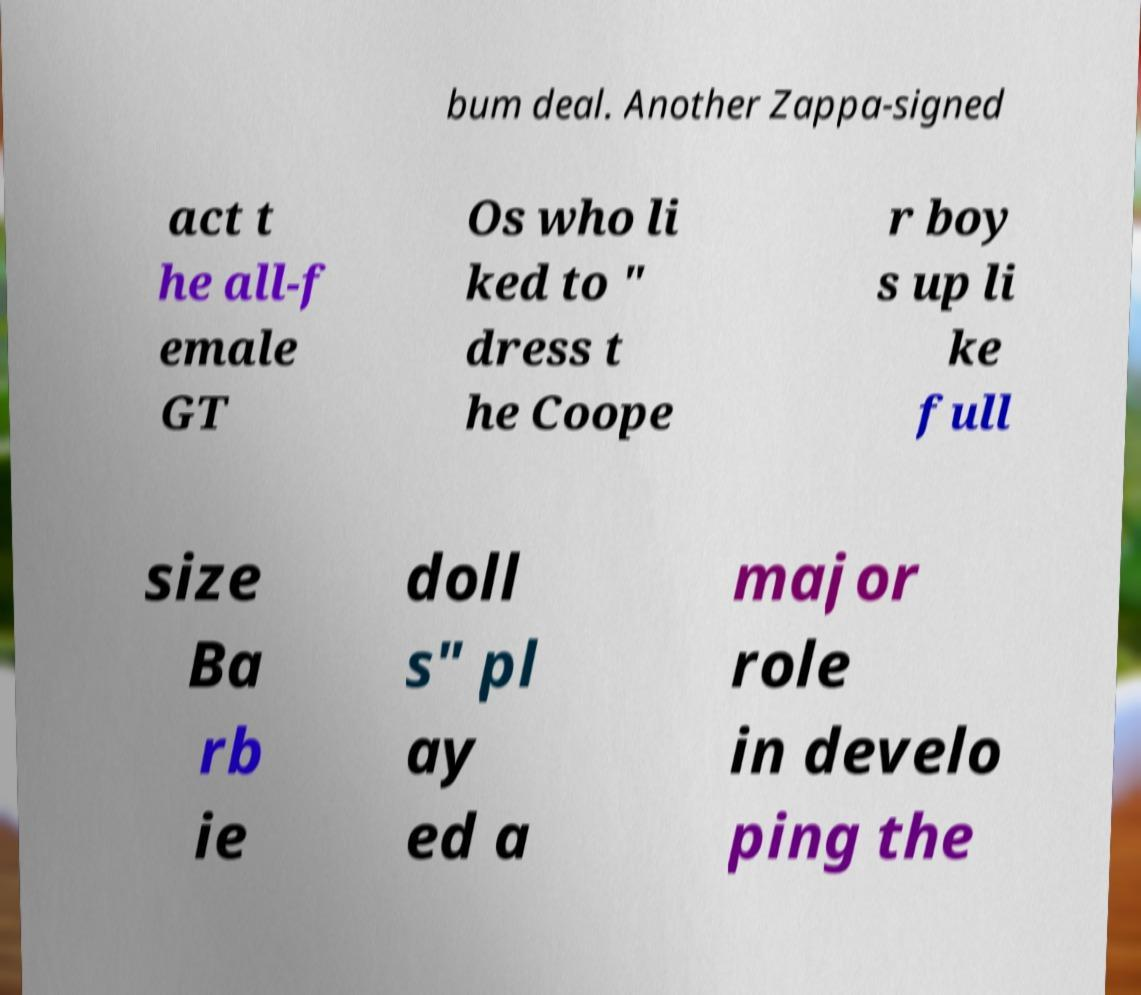Can you accurately transcribe the text from the provided image for me? bum deal. Another Zappa-signed act t he all-f emale GT Os who li ked to " dress t he Coope r boy s up li ke full size Ba rb ie doll s" pl ay ed a major role in develo ping the 